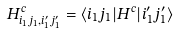Convert formula to latex. <formula><loc_0><loc_0><loc_500><loc_500>H ^ { c } _ { i _ { 1 } j _ { 1 } , i _ { 1 } ^ { \prime } j _ { 1 } ^ { \prime } } = \langle i _ { 1 } j _ { 1 } | { H } ^ { c } | i _ { 1 } ^ { \prime } j _ { 1 } ^ { \prime } \rangle</formula> 